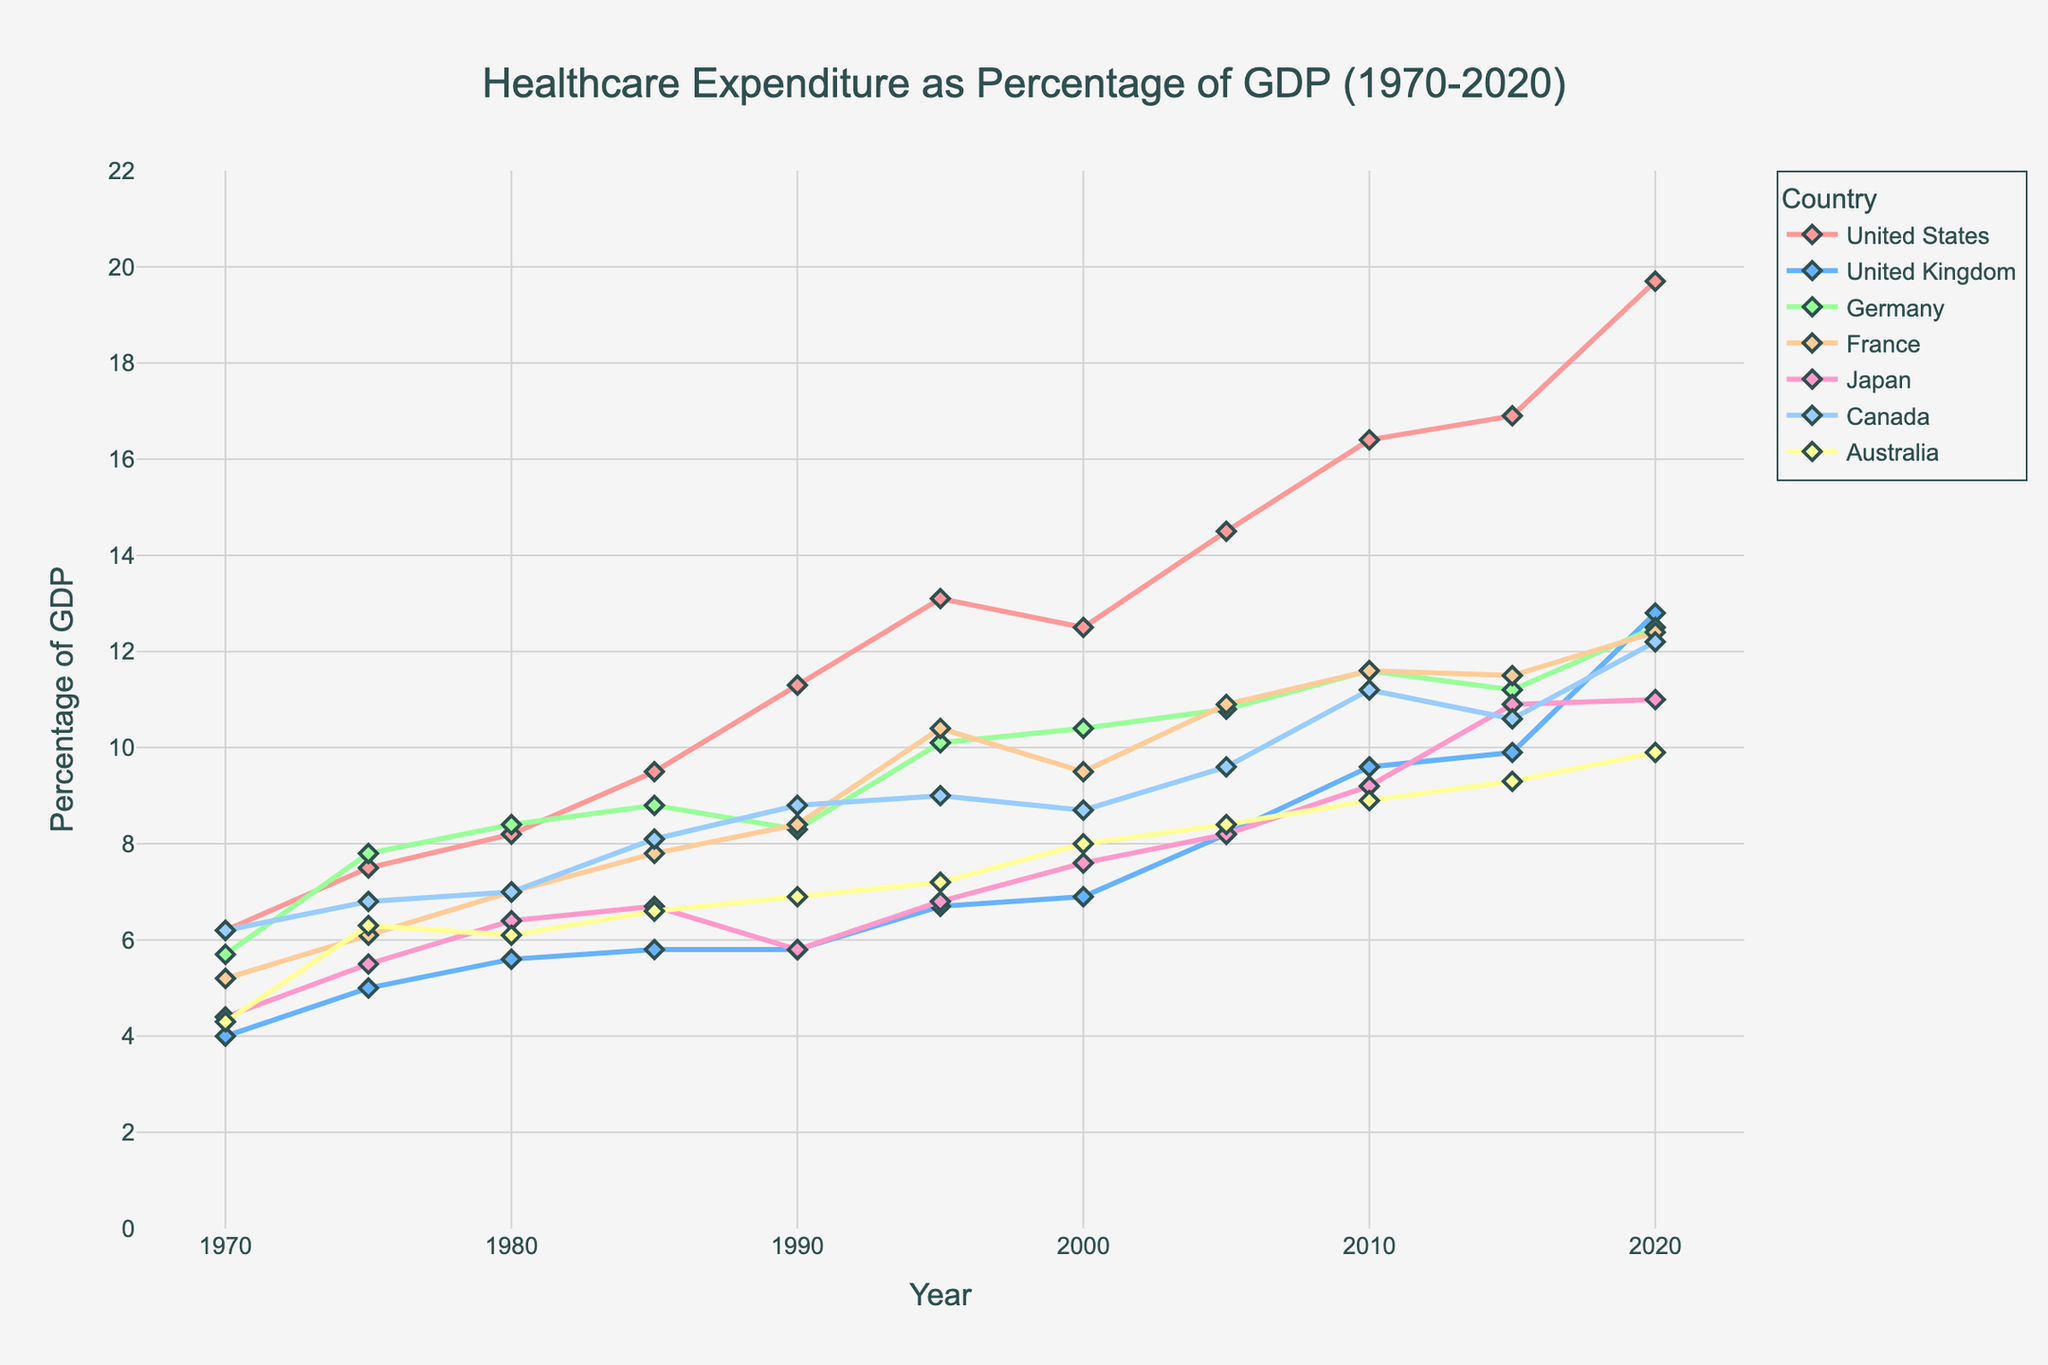What is the percentage of GDP spent on healthcare by the United States in 2020? In the figure, find the data point for the United States in the year 2020 and read the value directly from the graph.
Answer: 19.7 Which country spent the highest percentage of GDP on healthcare in 2010? Identify the country with the highest data point in the year 2010 by comparing the positions of the markers on the graph.
Answer: United States Compare the GDP percentage spent on healthcare by Germany and France in 2000. Which country spent more? Look for the data points corresponding to Germany and France in the year 2000 and compare their values.
Answer: Germany Calculate the average percentage of GDP spent on healthcare by Japan from 1970 to 1990. Add the values corresponding to Japan for the years 1970, 1975, 1980, 1985, and 1990, and then divide by 5 to find the average.
Answer: 5.76 What trend can you observe in the United States' percentage of GDP spent on healthcare from 1970 to 2020? Observe the line representing the United States from 1970 to 2020, noting the increasing direction and any significant changes.
Answer: Increasing trend Among United States, United Kingdom, and Canada, which country had the smallest increase in healthcare expenditure as a percentage of GDP from 1970 to 2020? Calculate the differences between percentage values for each country from 1970 to 2020, then compare these differences to identify the smallest increase.
Answer: Canada Which year did France first exceed 10% of GDP in healthcare expenditure? Examine the data points for France, noting the years and observing the first one that crosses the 10% threshold.
Answer: 1995 How many countries had healthcare expenditures as a percentage of GDP above 12% in 2020? Identify the countries with data points above 12% in 2020 by comparing their values to this threshold.
Answer: 4 Describe the difference in healthcare expenditure between Japan and Australia in 2015. Subtract the percentage of GDP spent by Australia from that of Japan for the year 2015.
Answer: 1.6 